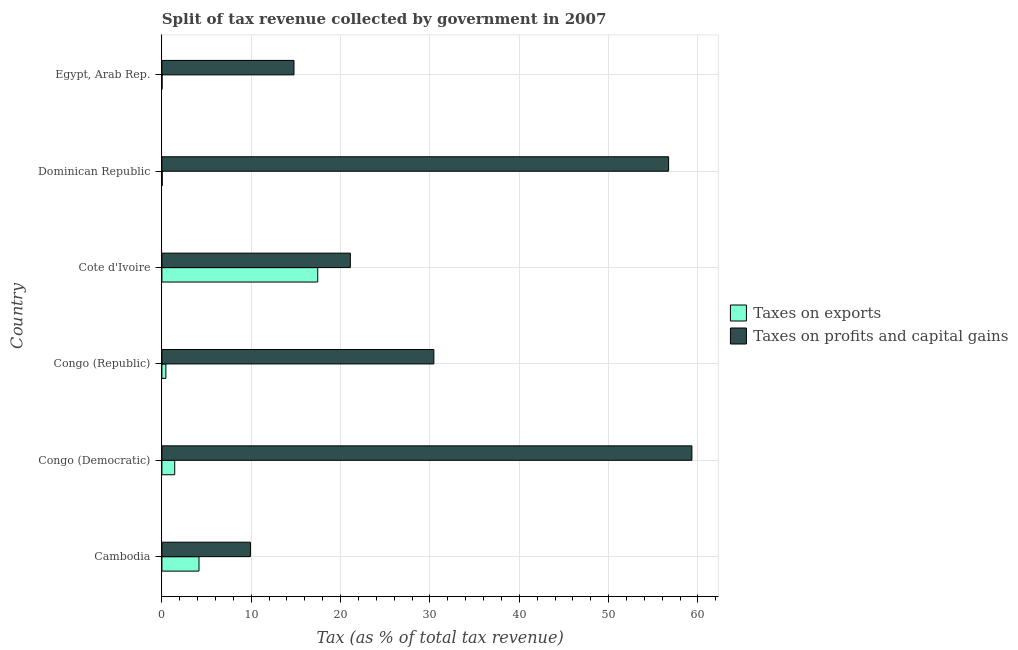How many different coloured bars are there?
Provide a succinct answer. 2. How many groups of bars are there?
Provide a short and direct response. 6. Are the number of bars per tick equal to the number of legend labels?
Provide a succinct answer. Yes. Are the number of bars on each tick of the Y-axis equal?
Provide a succinct answer. Yes. How many bars are there on the 6th tick from the top?
Your response must be concise. 2. How many bars are there on the 5th tick from the bottom?
Your answer should be compact. 2. What is the label of the 4th group of bars from the top?
Offer a terse response. Congo (Republic). In how many cases, is the number of bars for a given country not equal to the number of legend labels?
Ensure brevity in your answer.  0. What is the percentage of revenue obtained from taxes on profits and capital gains in Egypt, Arab Rep.?
Provide a short and direct response. 14.78. Across all countries, what is the maximum percentage of revenue obtained from taxes on profits and capital gains?
Make the answer very short. 59.32. Across all countries, what is the minimum percentage of revenue obtained from taxes on exports?
Your answer should be very brief. 0.02. In which country was the percentage of revenue obtained from taxes on profits and capital gains maximum?
Offer a terse response. Congo (Democratic). In which country was the percentage of revenue obtained from taxes on exports minimum?
Provide a succinct answer. Egypt, Arab Rep. What is the total percentage of revenue obtained from taxes on profits and capital gains in the graph?
Offer a terse response. 192.25. What is the difference between the percentage of revenue obtained from taxes on profits and capital gains in Congo (Republic) and that in Egypt, Arab Rep.?
Give a very brief answer. 15.65. What is the difference between the percentage of revenue obtained from taxes on profits and capital gains in Congo (Democratic) and the percentage of revenue obtained from taxes on exports in Cote d'Ivoire?
Ensure brevity in your answer.  41.88. What is the average percentage of revenue obtained from taxes on profits and capital gains per country?
Provide a succinct answer. 32.04. What is the difference between the percentage of revenue obtained from taxes on profits and capital gains and percentage of revenue obtained from taxes on exports in Dominican Republic?
Offer a terse response. 56.67. In how many countries, is the percentage of revenue obtained from taxes on exports greater than 6 %?
Provide a short and direct response. 1. What is the ratio of the percentage of revenue obtained from taxes on profits and capital gains in Cambodia to that in Congo (Democratic)?
Your answer should be compact. 0.17. What is the difference between the highest and the second highest percentage of revenue obtained from taxes on profits and capital gains?
Ensure brevity in your answer.  2.61. What is the difference between the highest and the lowest percentage of revenue obtained from taxes on exports?
Provide a succinct answer. 17.42. In how many countries, is the percentage of revenue obtained from taxes on profits and capital gains greater than the average percentage of revenue obtained from taxes on profits and capital gains taken over all countries?
Your response must be concise. 2. What does the 1st bar from the top in Cambodia represents?
Your answer should be very brief. Taxes on profits and capital gains. What does the 2nd bar from the bottom in Cote d'Ivoire represents?
Provide a short and direct response. Taxes on profits and capital gains. How many bars are there?
Your response must be concise. 12. Are all the bars in the graph horizontal?
Your response must be concise. Yes. How many countries are there in the graph?
Offer a terse response. 6. What is the difference between two consecutive major ticks on the X-axis?
Your answer should be very brief. 10. Does the graph contain grids?
Your answer should be very brief. Yes. How many legend labels are there?
Your answer should be very brief. 2. How are the legend labels stacked?
Offer a very short reply. Vertical. What is the title of the graph?
Keep it short and to the point. Split of tax revenue collected by government in 2007. Does "Arms imports" appear as one of the legend labels in the graph?
Your response must be concise. No. What is the label or title of the X-axis?
Keep it short and to the point. Tax (as % of total tax revenue). What is the label or title of the Y-axis?
Offer a very short reply. Country. What is the Tax (as % of total tax revenue) in Taxes on exports in Cambodia?
Your answer should be compact. 4.15. What is the Tax (as % of total tax revenue) in Taxes on profits and capital gains in Cambodia?
Offer a very short reply. 9.91. What is the Tax (as % of total tax revenue) in Taxes on exports in Congo (Democratic)?
Provide a succinct answer. 1.44. What is the Tax (as % of total tax revenue) in Taxes on profits and capital gains in Congo (Democratic)?
Provide a succinct answer. 59.32. What is the Tax (as % of total tax revenue) of Taxes on exports in Congo (Republic)?
Make the answer very short. 0.45. What is the Tax (as % of total tax revenue) in Taxes on profits and capital gains in Congo (Republic)?
Give a very brief answer. 30.44. What is the Tax (as % of total tax revenue) of Taxes on exports in Cote d'Ivoire?
Provide a succinct answer. 17.44. What is the Tax (as % of total tax revenue) of Taxes on profits and capital gains in Cote d'Ivoire?
Your answer should be very brief. 21.09. What is the Tax (as % of total tax revenue) of Taxes on exports in Dominican Republic?
Your response must be concise. 0.04. What is the Tax (as % of total tax revenue) of Taxes on profits and capital gains in Dominican Republic?
Offer a terse response. 56.71. What is the Tax (as % of total tax revenue) of Taxes on exports in Egypt, Arab Rep.?
Make the answer very short. 0.02. What is the Tax (as % of total tax revenue) in Taxes on profits and capital gains in Egypt, Arab Rep.?
Provide a short and direct response. 14.78. Across all countries, what is the maximum Tax (as % of total tax revenue) in Taxes on exports?
Offer a very short reply. 17.44. Across all countries, what is the maximum Tax (as % of total tax revenue) of Taxes on profits and capital gains?
Provide a short and direct response. 59.32. Across all countries, what is the minimum Tax (as % of total tax revenue) of Taxes on exports?
Ensure brevity in your answer.  0.02. Across all countries, what is the minimum Tax (as % of total tax revenue) of Taxes on profits and capital gains?
Keep it short and to the point. 9.91. What is the total Tax (as % of total tax revenue) of Taxes on exports in the graph?
Give a very brief answer. 23.53. What is the total Tax (as % of total tax revenue) of Taxes on profits and capital gains in the graph?
Provide a succinct answer. 192.25. What is the difference between the Tax (as % of total tax revenue) of Taxes on exports in Cambodia and that in Congo (Democratic)?
Keep it short and to the point. 2.72. What is the difference between the Tax (as % of total tax revenue) in Taxes on profits and capital gains in Cambodia and that in Congo (Democratic)?
Your answer should be very brief. -49.41. What is the difference between the Tax (as % of total tax revenue) of Taxes on exports in Cambodia and that in Congo (Republic)?
Give a very brief answer. 3.71. What is the difference between the Tax (as % of total tax revenue) of Taxes on profits and capital gains in Cambodia and that in Congo (Republic)?
Keep it short and to the point. -20.53. What is the difference between the Tax (as % of total tax revenue) of Taxes on exports in Cambodia and that in Cote d'Ivoire?
Your response must be concise. -13.29. What is the difference between the Tax (as % of total tax revenue) in Taxes on profits and capital gains in Cambodia and that in Cote d'Ivoire?
Your response must be concise. -11.18. What is the difference between the Tax (as % of total tax revenue) of Taxes on exports in Cambodia and that in Dominican Republic?
Your answer should be compact. 4.11. What is the difference between the Tax (as % of total tax revenue) of Taxes on profits and capital gains in Cambodia and that in Dominican Republic?
Your answer should be very brief. -46.81. What is the difference between the Tax (as % of total tax revenue) in Taxes on exports in Cambodia and that in Egypt, Arab Rep.?
Offer a very short reply. 4.13. What is the difference between the Tax (as % of total tax revenue) of Taxes on profits and capital gains in Cambodia and that in Egypt, Arab Rep.?
Provide a short and direct response. -4.88. What is the difference between the Tax (as % of total tax revenue) in Taxes on exports in Congo (Democratic) and that in Congo (Republic)?
Provide a short and direct response. 0.99. What is the difference between the Tax (as % of total tax revenue) of Taxes on profits and capital gains in Congo (Democratic) and that in Congo (Republic)?
Ensure brevity in your answer.  28.88. What is the difference between the Tax (as % of total tax revenue) in Taxes on exports in Congo (Democratic) and that in Cote d'Ivoire?
Give a very brief answer. -16.01. What is the difference between the Tax (as % of total tax revenue) of Taxes on profits and capital gains in Congo (Democratic) and that in Cote d'Ivoire?
Your answer should be very brief. 38.23. What is the difference between the Tax (as % of total tax revenue) of Taxes on exports in Congo (Democratic) and that in Dominican Republic?
Your response must be concise. 1.4. What is the difference between the Tax (as % of total tax revenue) of Taxes on profits and capital gains in Congo (Democratic) and that in Dominican Republic?
Provide a short and direct response. 2.61. What is the difference between the Tax (as % of total tax revenue) in Taxes on exports in Congo (Democratic) and that in Egypt, Arab Rep.?
Make the answer very short. 1.42. What is the difference between the Tax (as % of total tax revenue) in Taxes on profits and capital gains in Congo (Democratic) and that in Egypt, Arab Rep.?
Make the answer very short. 44.54. What is the difference between the Tax (as % of total tax revenue) of Taxes on exports in Congo (Republic) and that in Cote d'Ivoire?
Your answer should be compact. -17. What is the difference between the Tax (as % of total tax revenue) in Taxes on profits and capital gains in Congo (Republic) and that in Cote d'Ivoire?
Your answer should be very brief. 9.35. What is the difference between the Tax (as % of total tax revenue) of Taxes on exports in Congo (Republic) and that in Dominican Republic?
Your answer should be compact. 0.41. What is the difference between the Tax (as % of total tax revenue) of Taxes on profits and capital gains in Congo (Republic) and that in Dominican Republic?
Provide a short and direct response. -26.27. What is the difference between the Tax (as % of total tax revenue) in Taxes on exports in Congo (Republic) and that in Egypt, Arab Rep.?
Your answer should be very brief. 0.43. What is the difference between the Tax (as % of total tax revenue) of Taxes on profits and capital gains in Congo (Republic) and that in Egypt, Arab Rep.?
Your answer should be compact. 15.65. What is the difference between the Tax (as % of total tax revenue) of Taxes on exports in Cote d'Ivoire and that in Dominican Republic?
Provide a succinct answer. 17.41. What is the difference between the Tax (as % of total tax revenue) in Taxes on profits and capital gains in Cote d'Ivoire and that in Dominican Republic?
Make the answer very short. -35.62. What is the difference between the Tax (as % of total tax revenue) of Taxes on exports in Cote d'Ivoire and that in Egypt, Arab Rep.?
Offer a terse response. 17.42. What is the difference between the Tax (as % of total tax revenue) of Taxes on profits and capital gains in Cote d'Ivoire and that in Egypt, Arab Rep.?
Offer a terse response. 6.31. What is the difference between the Tax (as % of total tax revenue) of Taxes on exports in Dominican Republic and that in Egypt, Arab Rep.?
Provide a succinct answer. 0.02. What is the difference between the Tax (as % of total tax revenue) in Taxes on profits and capital gains in Dominican Republic and that in Egypt, Arab Rep.?
Provide a short and direct response. 41.93. What is the difference between the Tax (as % of total tax revenue) in Taxes on exports in Cambodia and the Tax (as % of total tax revenue) in Taxes on profits and capital gains in Congo (Democratic)?
Provide a short and direct response. -55.17. What is the difference between the Tax (as % of total tax revenue) in Taxes on exports in Cambodia and the Tax (as % of total tax revenue) in Taxes on profits and capital gains in Congo (Republic)?
Your answer should be compact. -26.29. What is the difference between the Tax (as % of total tax revenue) in Taxes on exports in Cambodia and the Tax (as % of total tax revenue) in Taxes on profits and capital gains in Cote d'Ivoire?
Make the answer very short. -16.94. What is the difference between the Tax (as % of total tax revenue) in Taxes on exports in Cambodia and the Tax (as % of total tax revenue) in Taxes on profits and capital gains in Dominican Republic?
Your answer should be compact. -52.56. What is the difference between the Tax (as % of total tax revenue) of Taxes on exports in Cambodia and the Tax (as % of total tax revenue) of Taxes on profits and capital gains in Egypt, Arab Rep.?
Your answer should be compact. -10.63. What is the difference between the Tax (as % of total tax revenue) in Taxes on exports in Congo (Democratic) and the Tax (as % of total tax revenue) in Taxes on profits and capital gains in Congo (Republic)?
Offer a very short reply. -29. What is the difference between the Tax (as % of total tax revenue) of Taxes on exports in Congo (Democratic) and the Tax (as % of total tax revenue) of Taxes on profits and capital gains in Cote d'Ivoire?
Provide a succinct answer. -19.66. What is the difference between the Tax (as % of total tax revenue) of Taxes on exports in Congo (Democratic) and the Tax (as % of total tax revenue) of Taxes on profits and capital gains in Dominican Republic?
Your answer should be compact. -55.28. What is the difference between the Tax (as % of total tax revenue) of Taxes on exports in Congo (Democratic) and the Tax (as % of total tax revenue) of Taxes on profits and capital gains in Egypt, Arab Rep.?
Offer a terse response. -13.35. What is the difference between the Tax (as % of total tax revenue) in Taxes on exports in Congo (Republic) and the Tax (as % of total tax revenue) in Taxes on profits and capital gains in Cote d'Ivoire?
Offer a very short reply. -20.64. What is the difference between the Tax (as % of total tax revenue) in Taxes on exports in Congo (Republic) and the Tax (as % of total tax revenue) in Taxes on profits and capital gains in Dominican Republic?
Your answer should be compact. -56.27. What is the difference between the Tax (as % of total tax revenue) of Taxes on exports in Congo (Republic) and the Tax (as % of total tax revenue) of Taxes on profits and capital gains in Egypt, Arab Rep.?
Your answer should be very brief. -14.34. What is the difference between the Tax (as % of total tax revenue) of Taxes on exports in Cote d'Ivoire and the Tax (as % of total tax revenue) of Taxes on profits and capital gains in Dominican Republic?
Provide a succinct answer. -39.27. What is the difference between the Tax (as % of total tax revenue) of Taxes on exports in Cote d'Ivoire and the Tax (as % of total tax revenue) of Taxes on profits and capital gains in Egypt, Arab Rep.?
Your answer should be compact. 2.66. What is the difference between the Tax (as % of total tax revenue) of Taxes on exports in Dominican Republic and the Tax (as % of total tax revenue) of Taxes on profits and capital gains in Egypt, Arab Rep.?
Provide a succinct answer. -14.75. What is the average Tax (as % of total tax revenue) of Taxes on exports per country?
Ensure brevity in your answer.  3.92. What is the average Tax (as % of total tax revenue) of Taxes on profits and capital gains per country?
Provide a succinct answer. 32.04. What is the difference between the Tax (as % of total tax revenue) in Taxes on exports and Tax (as % of total tax revenue) in Taxes on profits and capital gains in Cambodia?
Ensure brevity in your answer.  -5.75. What is the difference between the Tax (as % of total tax revenue) in Taxes on exports and Tax (as % of total tax revenue) in Taxes on profits and capital gains in Congo (Democratic)?
Ensure brevity in your answer.  -57.88. What is the difference between the Tax (as % of total tax revenue) of Taxes on exports and Tax (as % of total tax revenue) of Taxes on profits and capital gains in Congo (Republic)?
Your response must be concise. -29.99. What is the difference between the Tax (as % of total tax revenue) in Taxes on exports and Tax (as % of total tax revenue) in Taxes on profits and capital gains in Cote d'Ivoire?
Your response must be concise. -3.65. What is the difference between the Tax (as % of total tax revenue) of Taxes on exports and Tax (as % of total tax revenue) of Taxes on profits and capital gains in Dominican Republic?
Give a very brief answer. -56.67. What is the difference between the Tax (as % of total tax revenue) of Taxes on exports and Tax (as % of total tax revenue) of Taxes on profits and capital gains in Egypt, Arab Rep.?
Offer a terse response. -14.77. What is the ratio of the Tax (as % of total tax revenue) in Taxes on exports in Cambodia to that in Congo (Democratic)?
Your response must be concise. 2.89. What is the ratio of the Tax (as % of total tax revenue) in Taxes on profits and capital gains in Cambodia to that in Congo (Democratic)?
Ensure brevity in your answer.  0.17. What is the ratio of the Tax (as % of total tax revenue) in Taxes on exports in Cambodia to that in Congo (Republic)?
Offer a very short reply. 9.32. What is the ratio of the Tax (as % of total tax revenue) in Taxes on profits and capital gains in Cambodia to that in Congo (Republic)?
Give a very brief answer. 0.33. What is the ratio of the Tax (as % of total tax revenue) in Taxes on exports in Cambodia to that in Cote d'Ivoire?
Provide a short and direct response. 0.24. What is the ratio of the Tax (as % of total tax revenue) of Taxes on profits and capital gains in Cambodia to that in Cote d'Ivoire?
Ensure brevity in your answer.  0.47. What is the ratio of the Tax (as % of total tax revenue) of Taxes on exports in Cambodia to that in Dominican Republic?
Make the answer very short. 109.28. What is the ratio of the Tax (as % of total tax revenue) in Taxes on profits and capital gains in Cambodia to that in Dominican Republic?
Offer a terse response. 0.17. What is the ratio of the Tax (as % of total tax revenue) in Taxes on exports in Cambodia to that in Egypt, Arab Rep.?
Offer a terse response. 219.81. What is the ratio of the Tax (as % of total tax revenue) in Taxes on profits and capital gains in Cambodia to that in Egypt, Arab Rep.?
Your answer should be compact. 0.67. What is the ratio of the Tax (as % of total tax revenue) of Taxes on exports in Congo (Democratic) to that in Congo (Republic)?
Offer a terse response. 3.22. What is the ratio of the Tax (as % of total tax revenue) in Taxes on profits and capital gains in Congo (Democratic) to that in Congo (Republic)?
Your answer should be compact. 1.95. What is the ratio of the Tax (as % of total tax revenue) in Taxes on exports in Congo (Democratic) to that in Cote d'Ivoire?
Your response must be concise. 0.08. What is the ratio of the Tax (as % of total tax revenue) in Taxes on profits and capital gains in Congo (Democratic) to that in Cote d'Ivoire?
Ensure brevity in your answer.  2.81. What is the ratio of the Tax (as % of total tax revenue) of Taxes on exports in Congo (Democratic) to that in Dominican Republic?
Keep it short and to the point. 37.76. What is the ratio of the Tax (as % of total tax revenue) of Taxes on profits and capital gains in Congo (Democratic) to that in Dominican Republic?
Offer a terse response. 1.05. What is the ratio of the Tax (as % of total tax revenue) in Taxes on exports in Congo (Democratic) to that in Egypt, Arab Rep.?
Provide a short and direct response. 75.96. What is the ratio of the Tax (as % of total tax revenue) of Taxes on profits and capital gains in Congo (Democratic) to that in Egypt, Arab Rep.?
Your answer should be very brief. 4.01. What is the ratio of the Tax (as % of total tax revenue) in Taxes on exports in Congo (Republic) to that in Cote d'Ivoire?
Give a very brief answer. 0.03. What is the ratio of the Tax (as % of total tax revenue) of Taxes on profits and capital gains in Congo (Republic) to that in Cote d'Ivoire?
Offer a very short reply. 1.44. What is the ratio of the Tax (as % of total tax revenue) in Taxes on exports in Congo (Republic) to that in Dominican Republic?
Make the answer very short. 11.73. What is the ratio of the Tax (as % of total tax revenue) in Taxes on profits and capital gains in Congo (Republic) to that in Dominican Republic?
Ensure brevity in your answer.  0.54. What is the ratio of the Tax (as % of total tax revenue) in Taxes on exports in Congo (Republic) to that in Egypt, Arab Rep.?
Ensure brevity in your answer.  23.59. What is the ratio of the Tax (as % of total tax revenue) of Taxes on profits and capital gains in Congo (Republic) to that in Egypt, Arab Rep.?
Offer a terse response. 2.06. What is the ratio of the Tax (as % of total tax revenue) of Taxes on exports in Cote d'Ivoire to that in Dominican Republic?
Provide a short and direct response. 458.98. What is the ratio of the Tax (as % of total tax revenue) in Taxes on profits and capital gains in Cote d'Ivoire to that in Dominican Republic?
Offer a terse response. 0.37. What is the ratio of the Tax (as % of total tax revenue) in Taxes on exports in Cote d'Ivoire to that in Egypt, Arab Rep.?
Your answer should be very brief. 923.24. What is the ratio of the Tax (as % of total tax revenue) in Taxes on profits and capital gains in Cote d'Ivoire to that in Egypt, Arab Rep.?
Keep it short and to the point. 1.43. What is the ratio of the Tax (as % of total tax revenue) in Taxes on exports in Dominican Republic to that in Egypt, Arab Rep.?
Provide a succinct answer. 2.01. What is the ratio of the Tax (as % of total tax revenue) of Taxes on profits and capital gains in Dominican Republic to that in Egypt, Arab Rep.?
Make the answer very short. 3.84. What is the difference between the highest and the second highest Tax (as % of total tax revenue) in Taxes on exports?
Provide a short and direct response. 13.29. What is the difference between the highest and the second highest Tax (as % of total tax revenue) of Taxes on profits and capital gains?
Your response must be concise. 2.61. What is the difference between the highest and the lowest Tax (as % of total tax revenue) in Taxes on exports?
Your answer should be very brief. 17.42. What is the difference between the highest and the lowest Tax (as % of total tax revenue) in Taxes on profits and capital gains?
Ensure brevity in your answer.  49.41. 